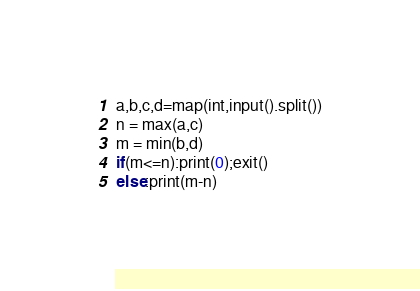<code> <loc_0><loc_0><loc_500><loc_500><_Python_>a,b,c,d=map(int,input().split())
n = max(a,c)
m = min(b,d)
if(m<=n):print(0);exit()
else:print(m-n)</code> 